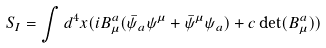Convert formula to latex. <formula><loc_0><loc_0><loc_500><loc_500>S _ { I } = \int d ^ { 4 } x ( i B _ { \mu } ^ { a } ( \bar { \psi } _ { a } \psi ^ { \mu } + \bar { \psi } ^ { \mu } \psi _ { a } ) + c \det ( B ^ { a } _ { \mu } ) )</formula> 